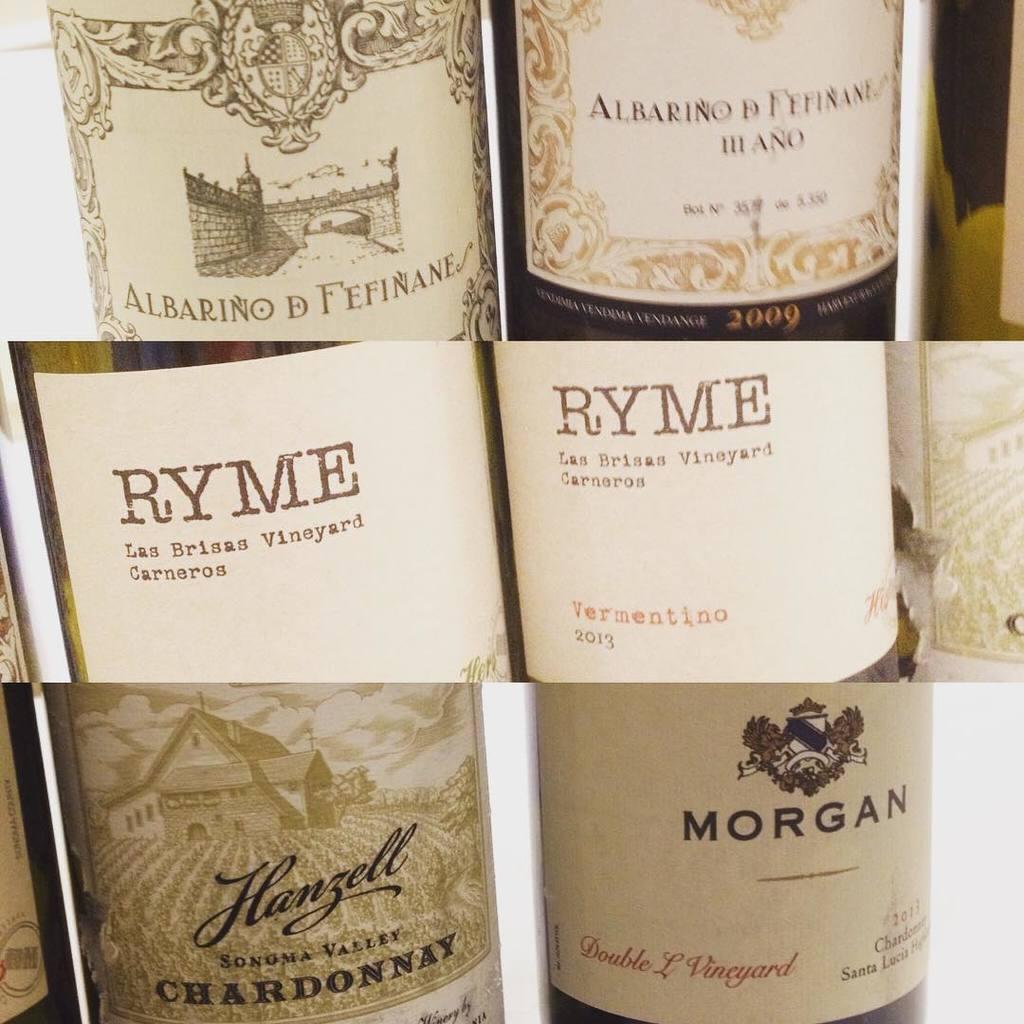Could you give a brief overview of what you see in this image? In this image we can see collage pictures of a beverage bottle. 